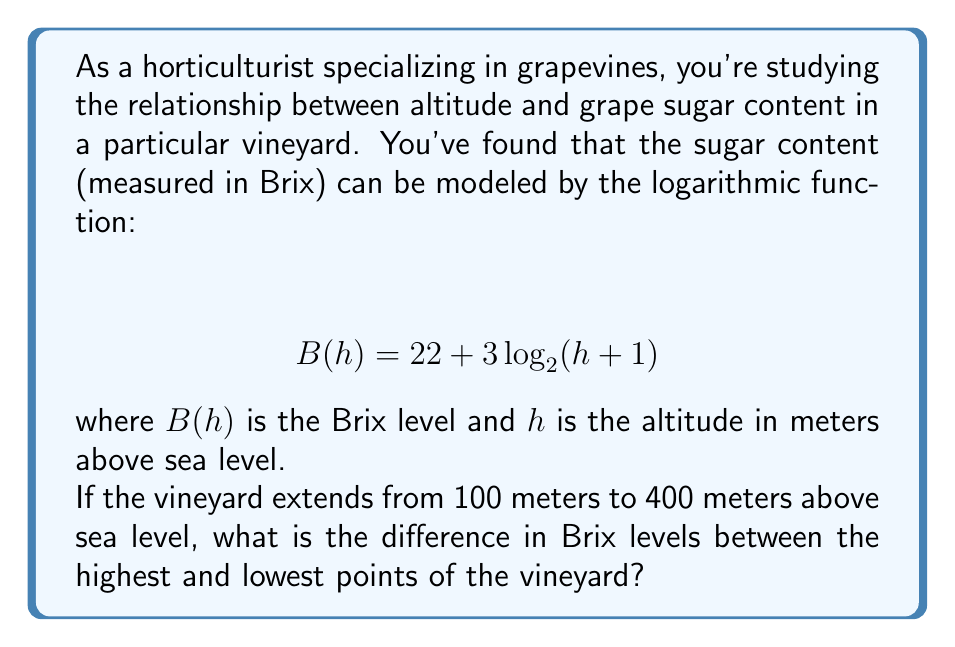Solve this math problem. To solve this problem, we need to follow these steps:

1) Calculate the Brix level at the lowest point (100 meters):
   $$ B(100) = 22 + 3\log_2(100+1) $$
   $$ = 22 + 3\log_2(101) $$
   $$ \approx 22 + 3(6.6582) $$
   $$ \approx 41.9746 $$

2) Calculate the Brix level at the highest point (400 meters):
   $$ B(400) = 22 + 3\log_2(400+1) $$
   $$ = 22 + 3\log_2(401) $$
   $$ \approx 22 + 3(8.6479) $$
   $$ \approx 47.9437 $$

3) Find the difference between these two values:
   $$ 47.9437 - 41.9746 \approx 5.9691 $$

This difference represents the increase in Brix levels from the lowest to the highest point in the vineyard.

The logarithmic function models the diminishing returns of increased altitude on sugar content, which is consistent with the complex relationship between altitude and grape quality in viticulture.
Answer: The difference in Brix levels between the highest and lowest points of the vineyard is approximately 5.97 Brix. 